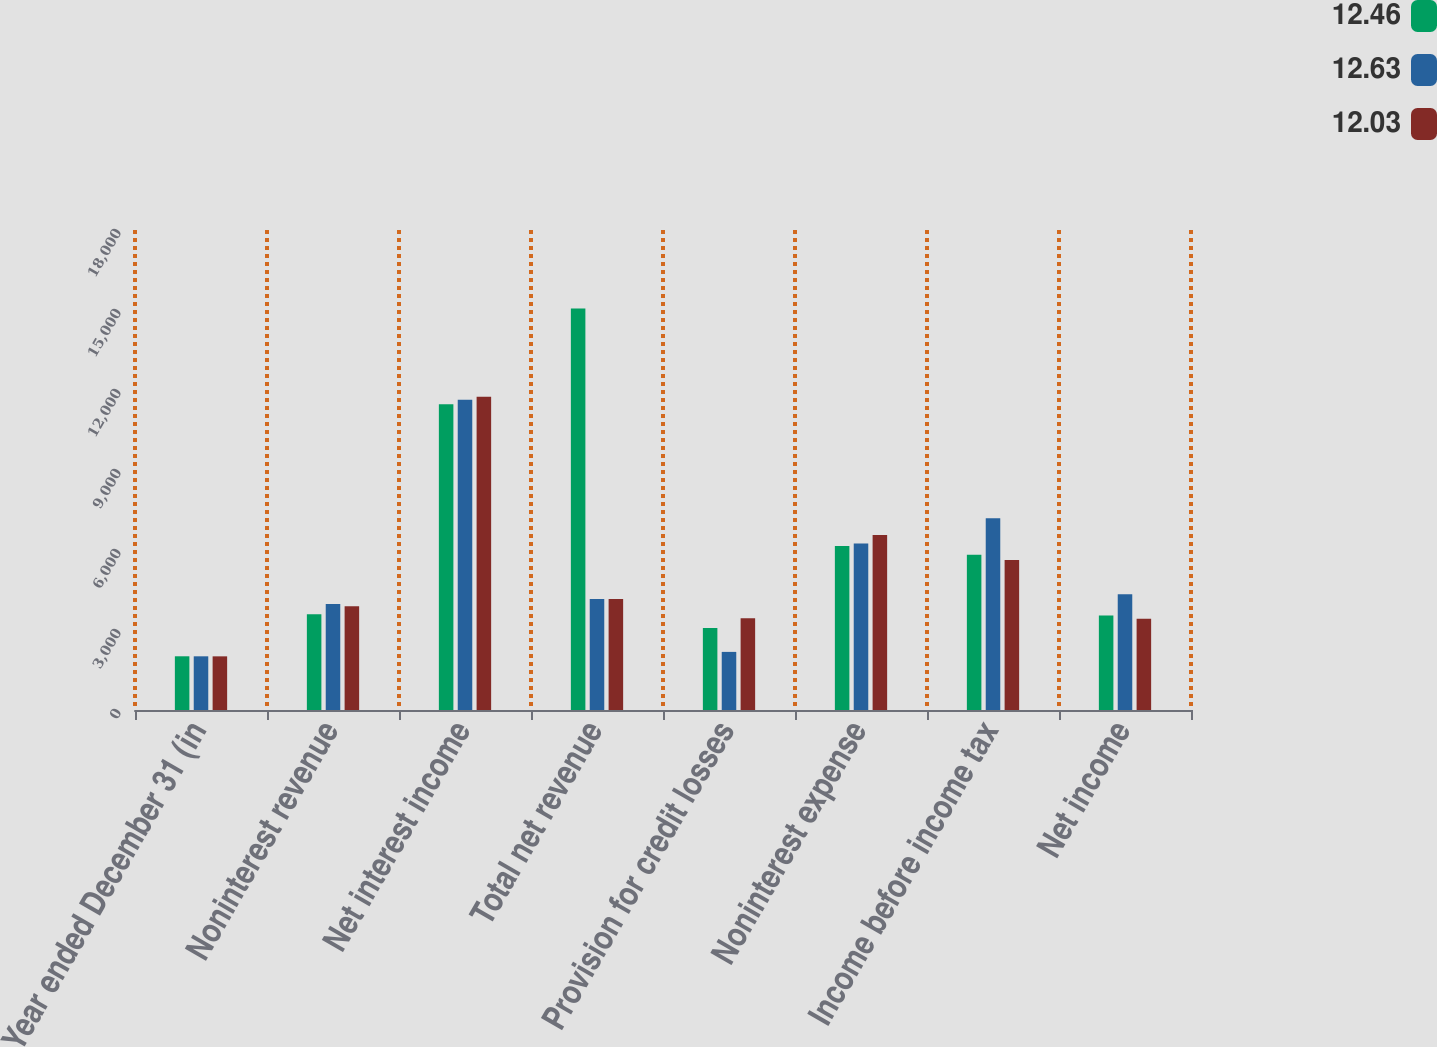Convert chart. <chart><loc_0><loc_0><loc_500><loc_500><stacked_bar_chart><ecel><fcel>Year ended December 31 (in<fcel>Noninterest revenue<fcel>Net interest income<fcel>Total net revenue<fcel>Provision for credit losses<fcel>Noninterest expense<fcel>Income before income tax<fcel>Net income<nl><fcel>12.46<fcel>2014<fcel>3593<fcel>11462<fcel>15055<fcel>3079<fcel>6152<fcel>5824<fcel>3547<nl><fcel>12.63<fcel>2013<fcel>3977<fcel>11638<fcel>4158.5<fcel>2179<fcel>6245<fcel>7191<fcel>4340<nl><fcel>12.03<fcel>2012<fcel>3887<fcel>11745<fcel>4158.5<fcel>3444<fcel>6566<fcel>5622<fcel>3426<nl></chart> 